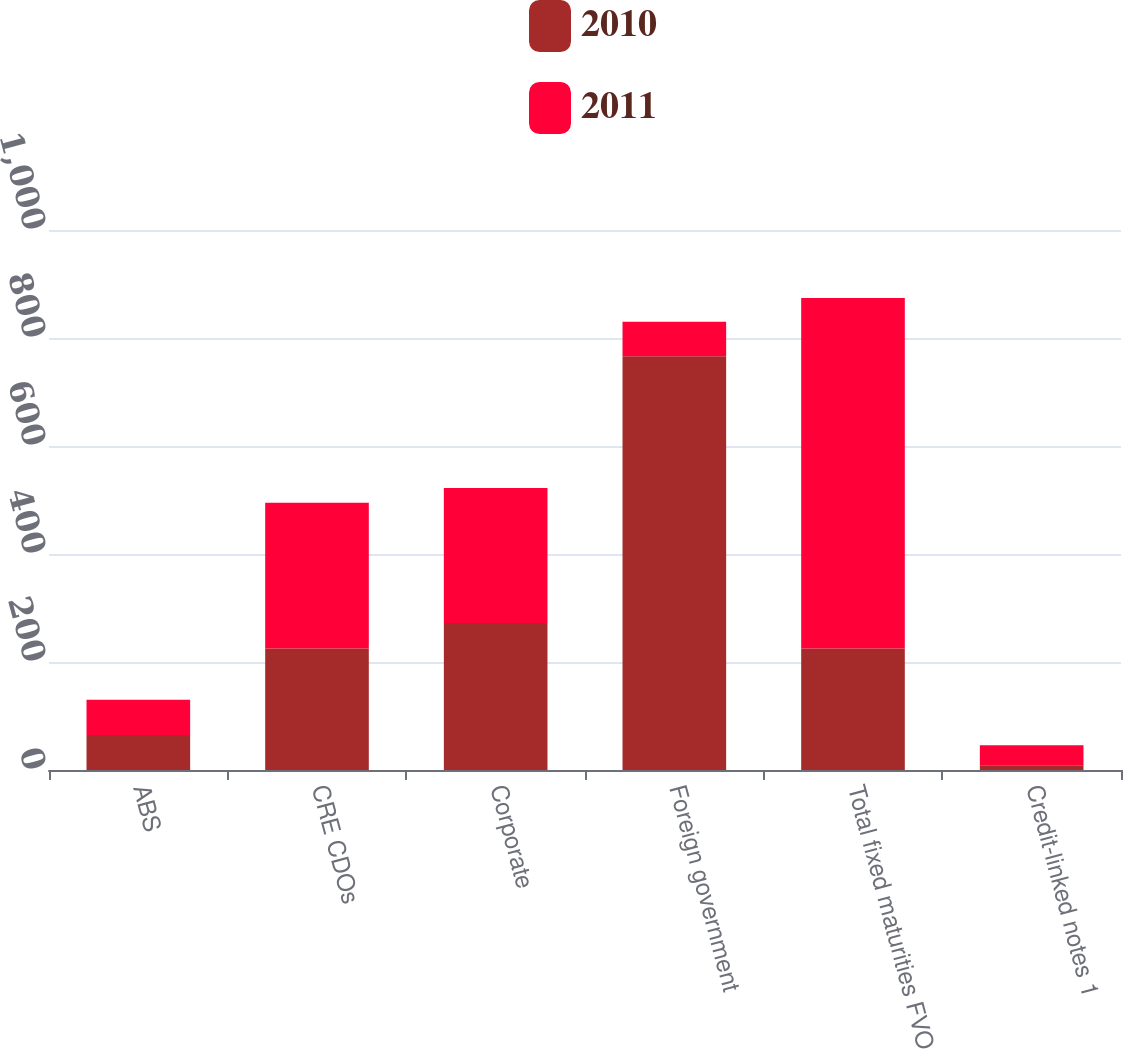Convert chart to OTSL. <chart><loc_0><loc_0><loc_500><loc_500><stacked_bar_chart><ecel><fcel>ABS<fcel>CRE CDOs<fcel>Corporate<fcel>Foreign government<fcel>Total fixed maturities FVO<fcel>Credit-linked notes 1<nl><fcel>2010<fcel>65<fcel>225<fcel>272<fcel>766<fcel>225<fcel>9<nl><fcel>2011<fcel>65<fcel>270<fcel>250<fcel>64<fcel>649<fcel>37<nl></chart> 